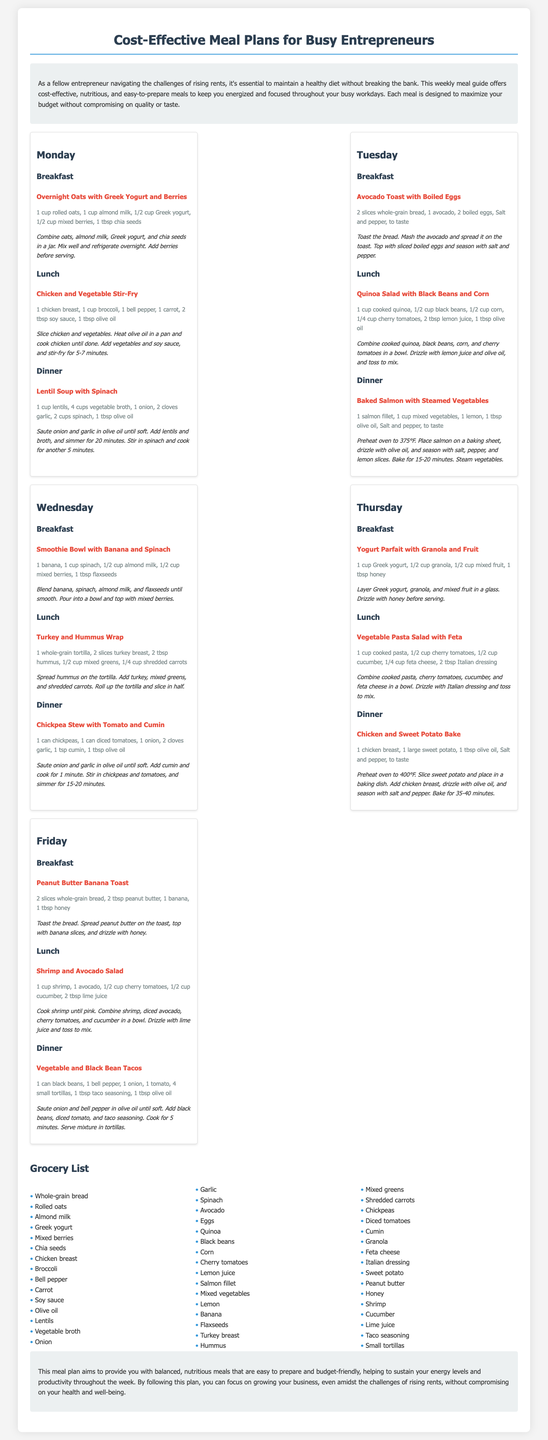What is the title of the document? The title of the document is presented at the top of the rendered page as a heading.
Answer: Cost-Effective Meal Plans for Busy Entrepreneurs How many meals are suggested for each day? Each day features three meals: breakfast, lunch, and dinner.
Answer: Three What is the main purpose of this meal plan? The main purpose is stated in the introduction, focusing on maintaining a healthy diet on a budget.
Answer: Balanced Nutrition and Budgeting What ingredient is used for breakfast on Tuesday? The breakfast for Tuesday includes specific ingredients that can be found in the listed meals.
Answer: Avocado Which day features a dinner of Chickpea Stew? The document provides a meal plan for each day, indicating what is served for dinner.
Answer: Wednesday How many calories do the suggested meals typically provide? The document does not specify calorie counts but emphasizes nutritious and cost-effective meals.
Answer: Not specified What is one ingredient required for the Chicken and Vegetable Stir-Fry? The recipe for Chicken and Vegetable Stir-Fry lists several ingredients.
Answer: Chicken breast Which fruit is listed in the grocery list? The grocery list contains various items, including fruits mentioned within meals throughout the week.
Answer: Banana What type of salad is suggested for lunch on Friday? The lunch option for Friday is detailed in the meal plan section specifically for that day.
Answer: Shrimp and Avocado Salad 